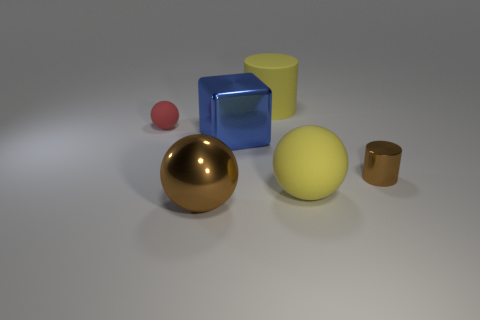What size is the blue cube?
Make the answer very short. Large. What material is the small cylinder that is the same color as the metallic sphere?
Offer a very short reply. Metal. There is a matte thing that is on the right side of the large brown thing and behind the tiny brown cylinder; what shape is it?
Offer a very short reply. Cylinder. What is the material of the brown object that is in front of the big matte object in front of the red matte ball?
Make the answer very short. Metal. Are there more big matte spheres than tiny yellow matte balls?
Give a very brief answer. Yes. Do the block and the tiny metal thing have the same color?
Give a very brief answer. No. There is a ball that is the same size as the brown shiny cylinder; what is it made of?
Offer a terse response. Rubber. Is the small brown cylinder made of the same material as the small red object?
Offer a terse response. No. How many brown cylinders have the same material as the large cube?
Your answer should be compact. 1. How many objects are either matte objects behind the brown cylinder or balls that are left of the blue metal block?
Provide a short and direct response. 3. 